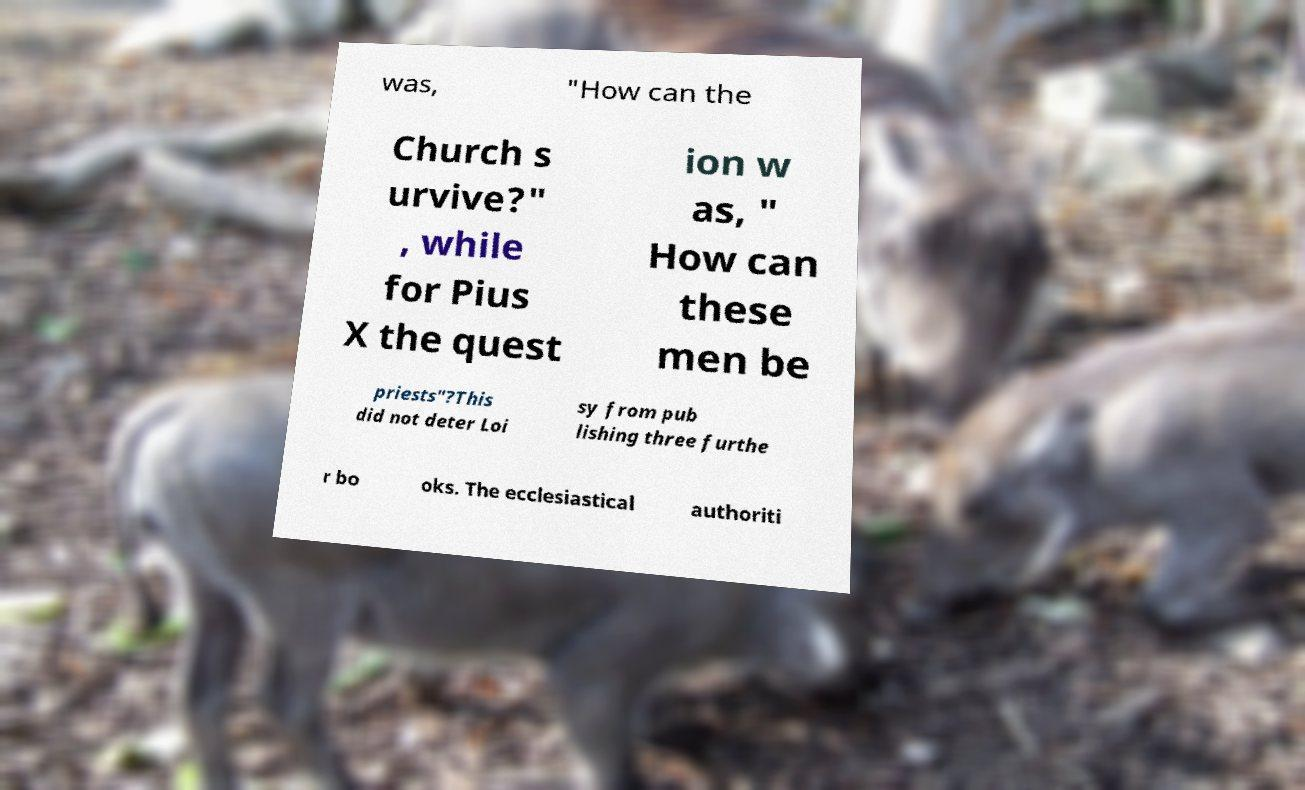Could you assist in decoding the text presented in this image and type it out clearly? was, "How can the Church s urvive?" , while for Pius X the quest ion w as, " How can these men be priests"?This did not deter Loi sy from pub lishing three furthe r bo oks. The ecclesiastical authoriti 